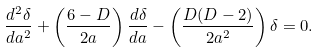Convert formula to latex. <formula><loc_0><loc_0><loc_500><loc_500>\frac { d ^ { 2 } \delta } { d a ^ { 2 } } + \left ( \frac { 6 - D } { 2 a } \right ) \frac { d \delta } { d a } - \left ( \frac { D ( D - 2 ) } { 2 a ^ { 2 } } \right ) \delta = 0 .</formula> 